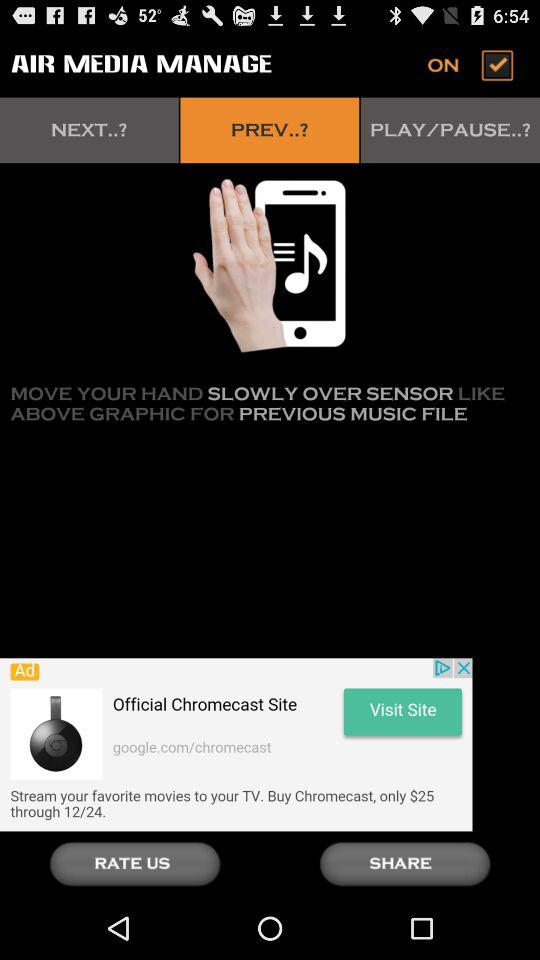How many items are in "NEXT..?"?
When the provided information is insufficient, respond with <no answer>. <no answer> 